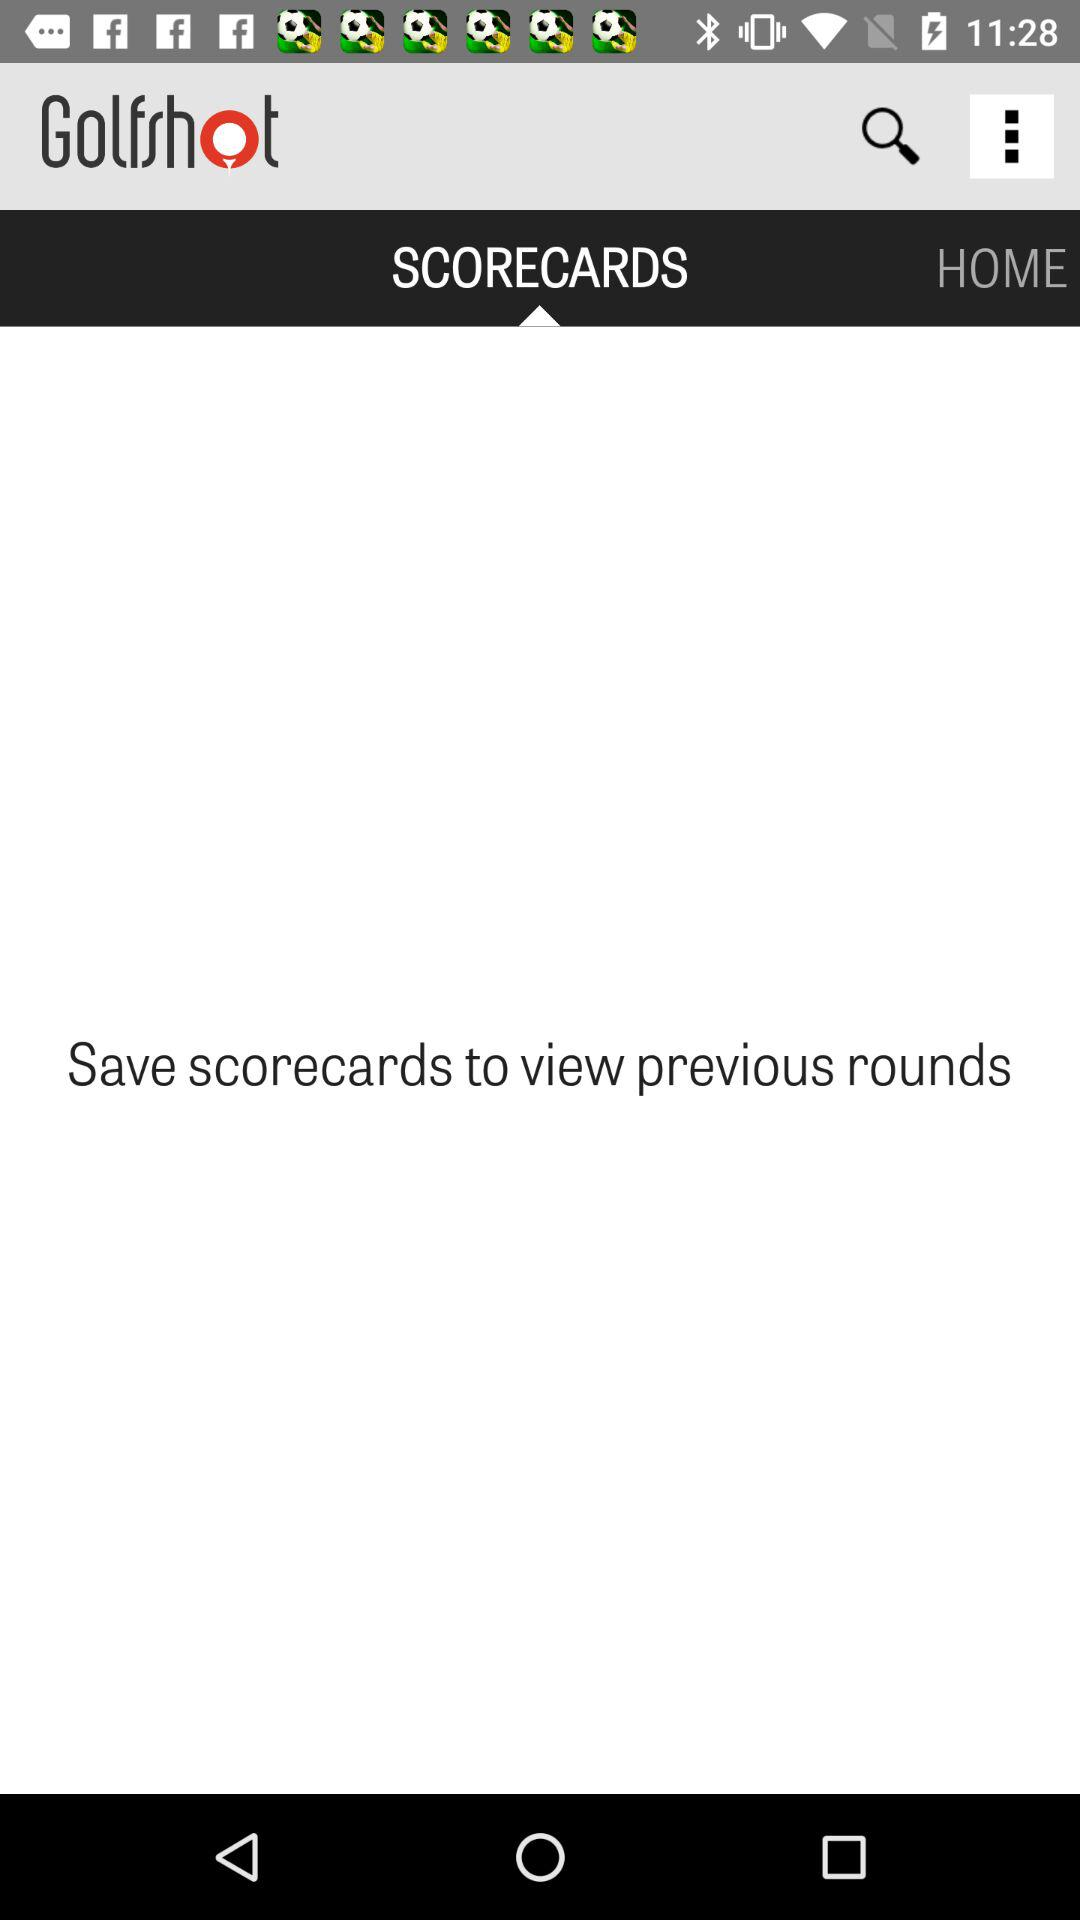What is the name of the application? The name of the application is "Golfshot". 